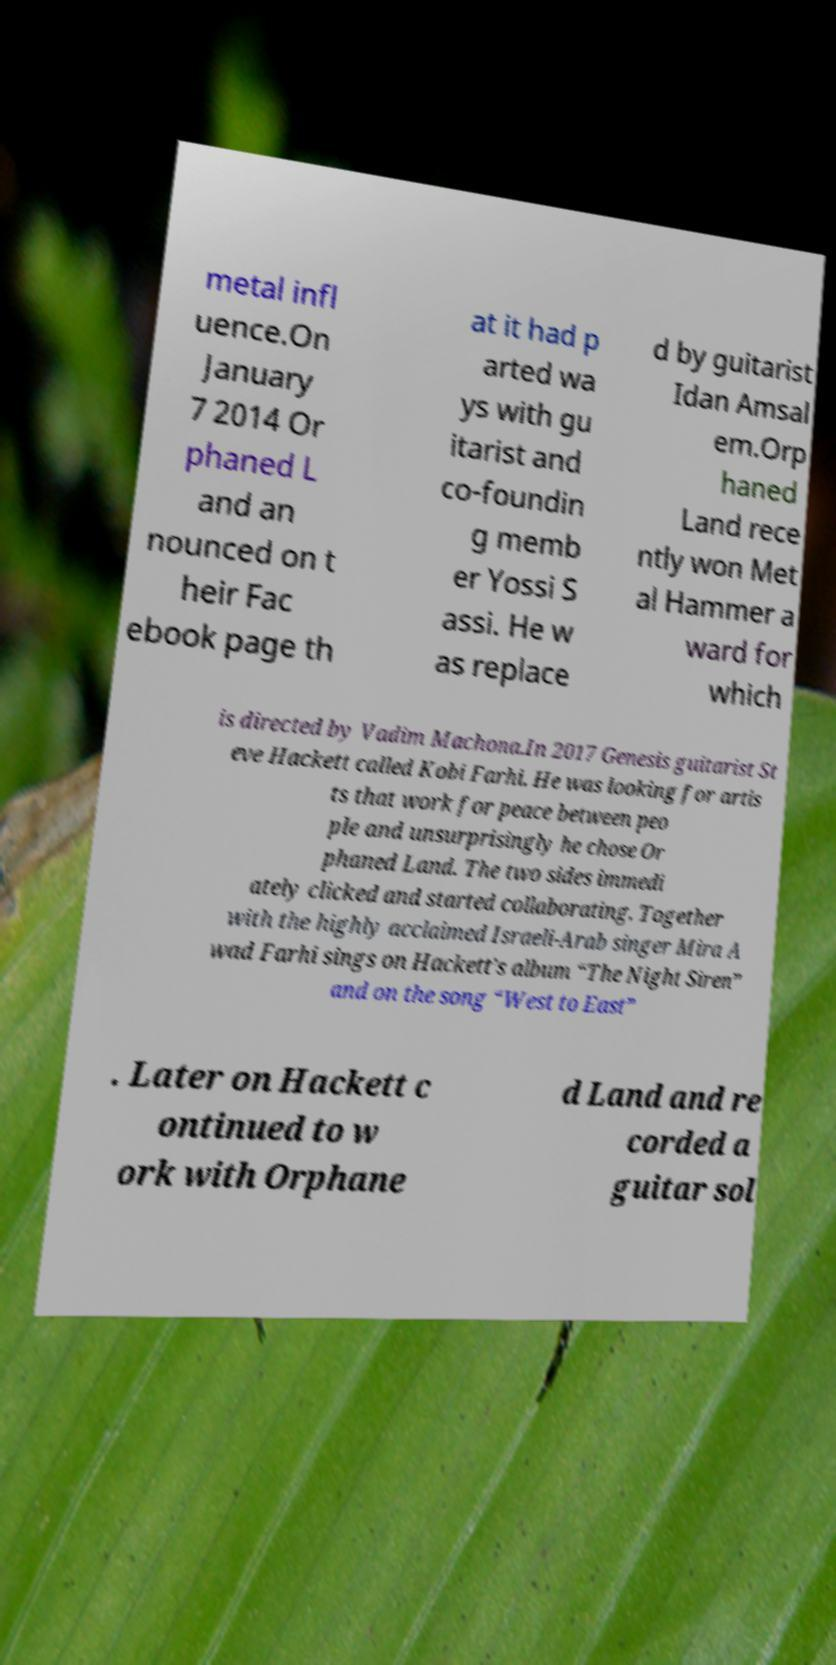Can you read and provide the text displayed in the image?This photo seems to have some interesting text. Can you extract and type it out for me? metal infl uence.On January 7 2014 Or phaned L and an nounced on t heir Fac ebook page th at it had p arted wa ys with gu itarist and co-foundin g memb er Yossi S assi. He w as replace d by guitarist Idan Amsal em.Orp haned Land rece ntly won Met al Hammer a ward for which is directed by Vadim Machona.In 2017 Genesis guitarist St eve Hackett called Kobi Farhi. He was looking for artis ts that work for peace between peo ple and unsurprisingly he chose Or phaned Land. The two sides immedi ately clicked and started collaborating. Together with the highly acclaimed Israeli-Arab singer Mira A wad Farhi sings on Hackett’s album “The Night Siren” and on the song “West to East” . Later on Hackett c ontinued to w ork with Orphane d Land and re corded a guitar sol 